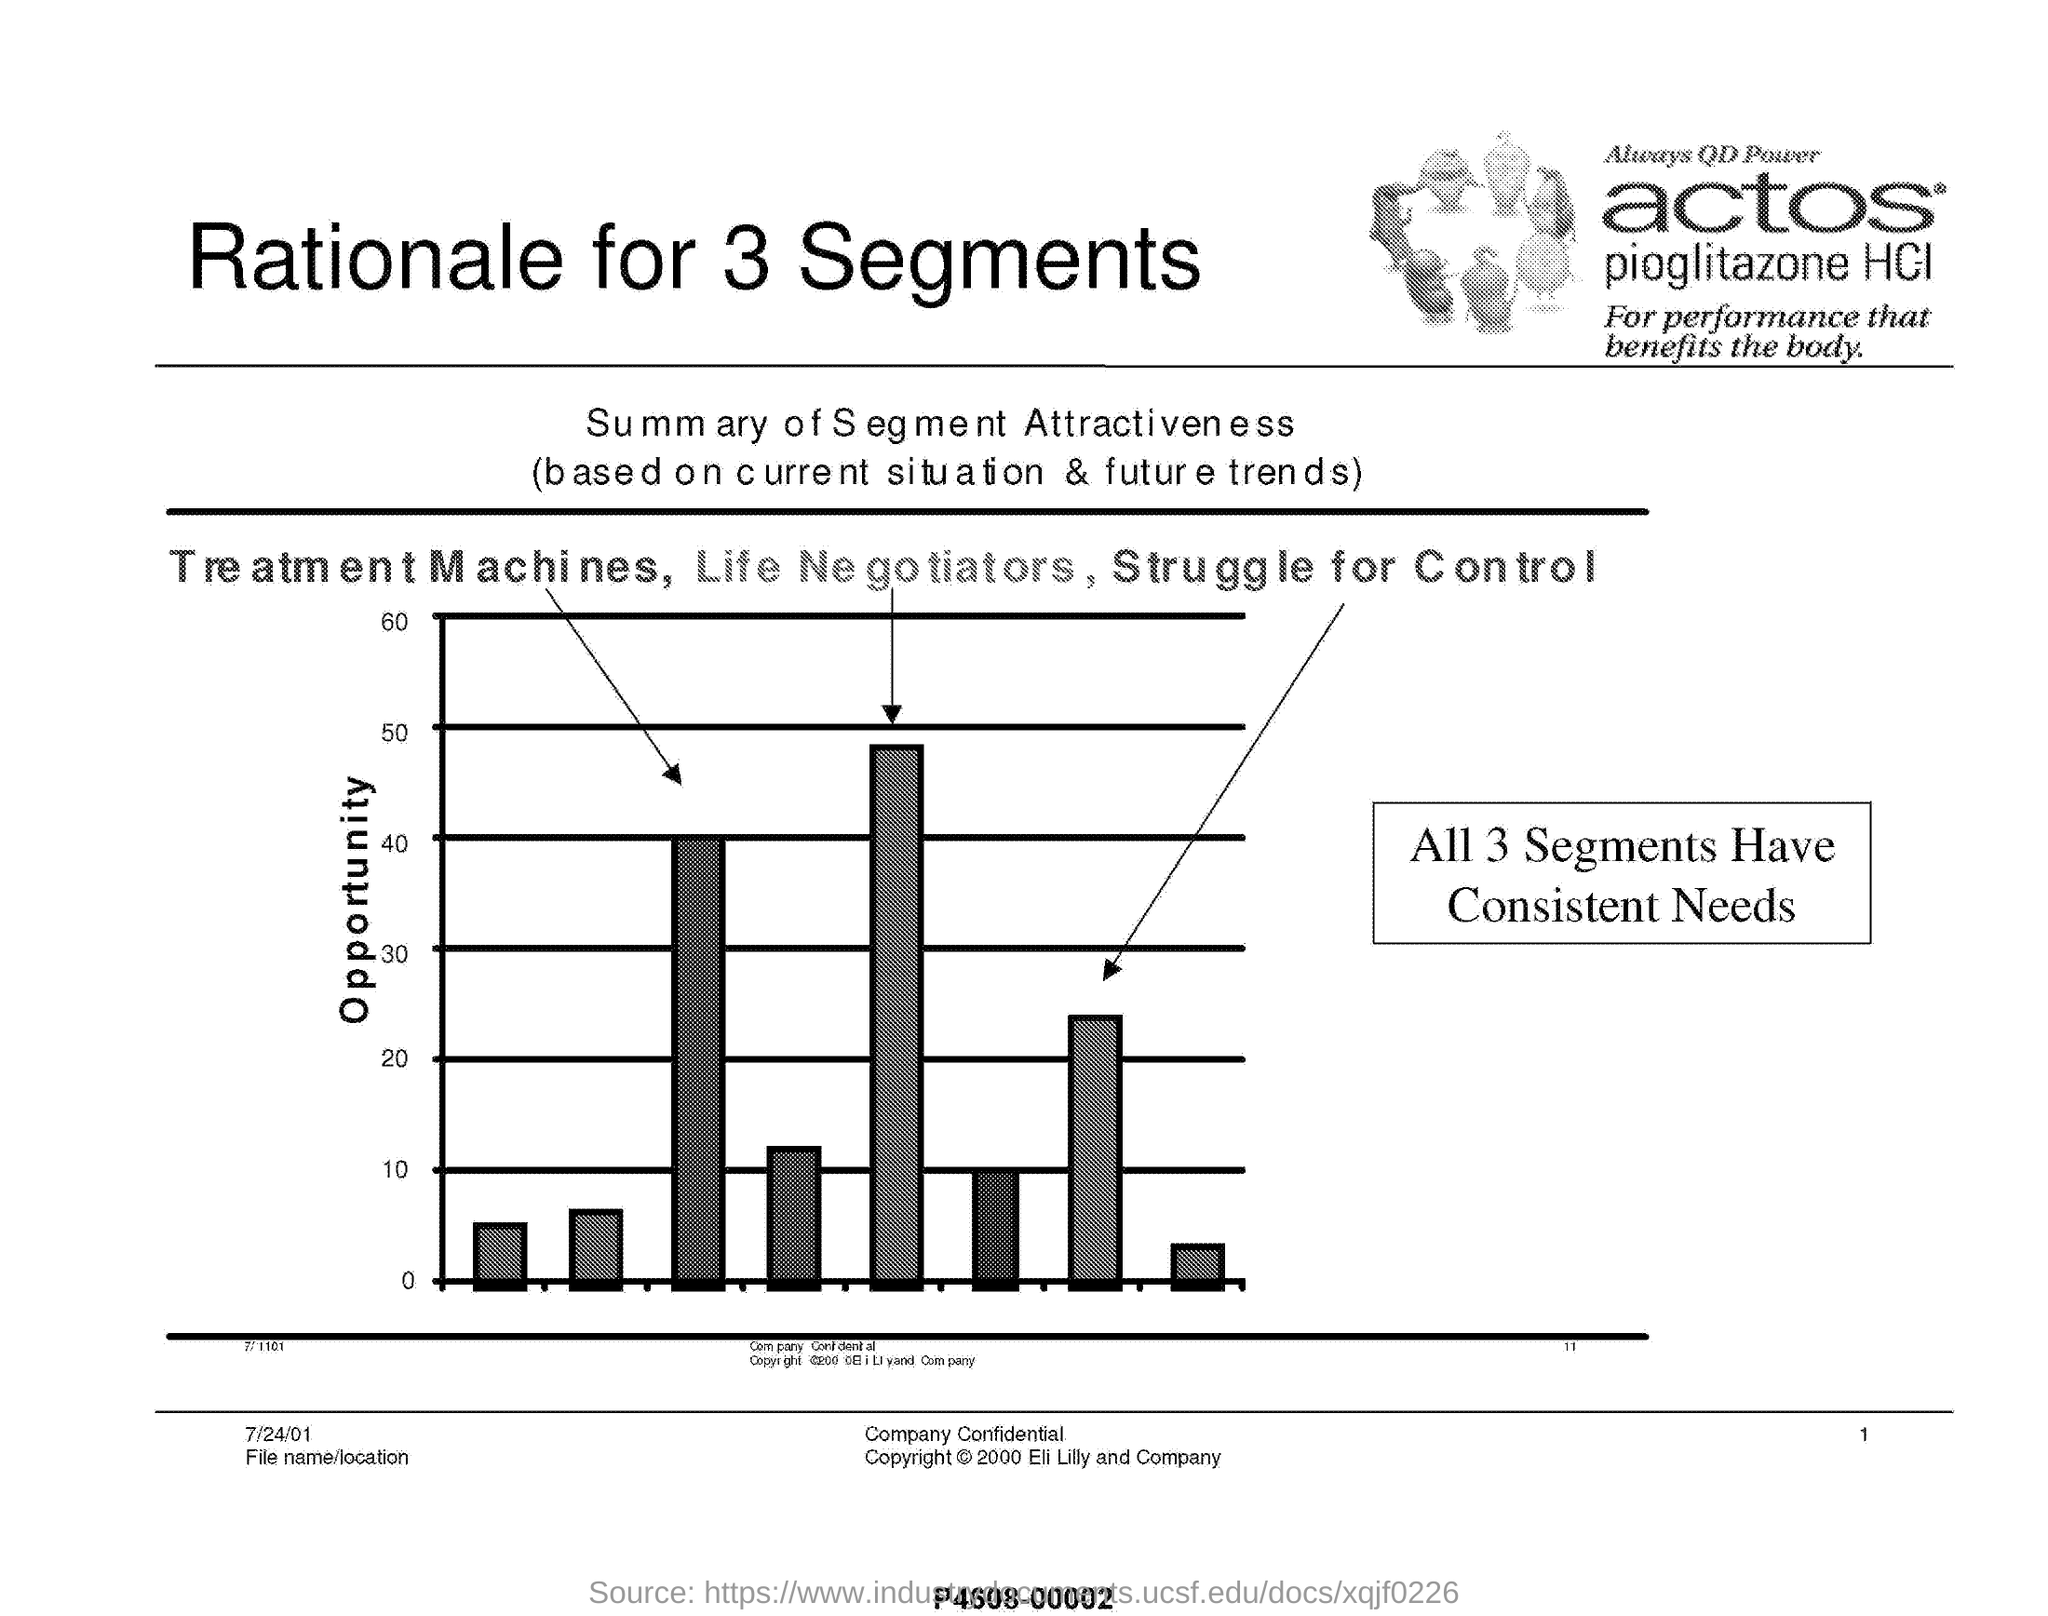Specify some key components in this picture. The Summary of Segment Attractiveness is determined based on the current situation and future trends of each segment. The graphical representation provides a summary of the segment attractiveness based on various factors such as market size and growth potential. The conclusion that can be obtained from the graph is that all three segments have consistent needs. The three segments indicated in the graph are: Treatment Machines, Life Negotiators, and Struggle for Control. This document contains a heading that asks for the heading of the document itself, with a rationale provided for three segments. 